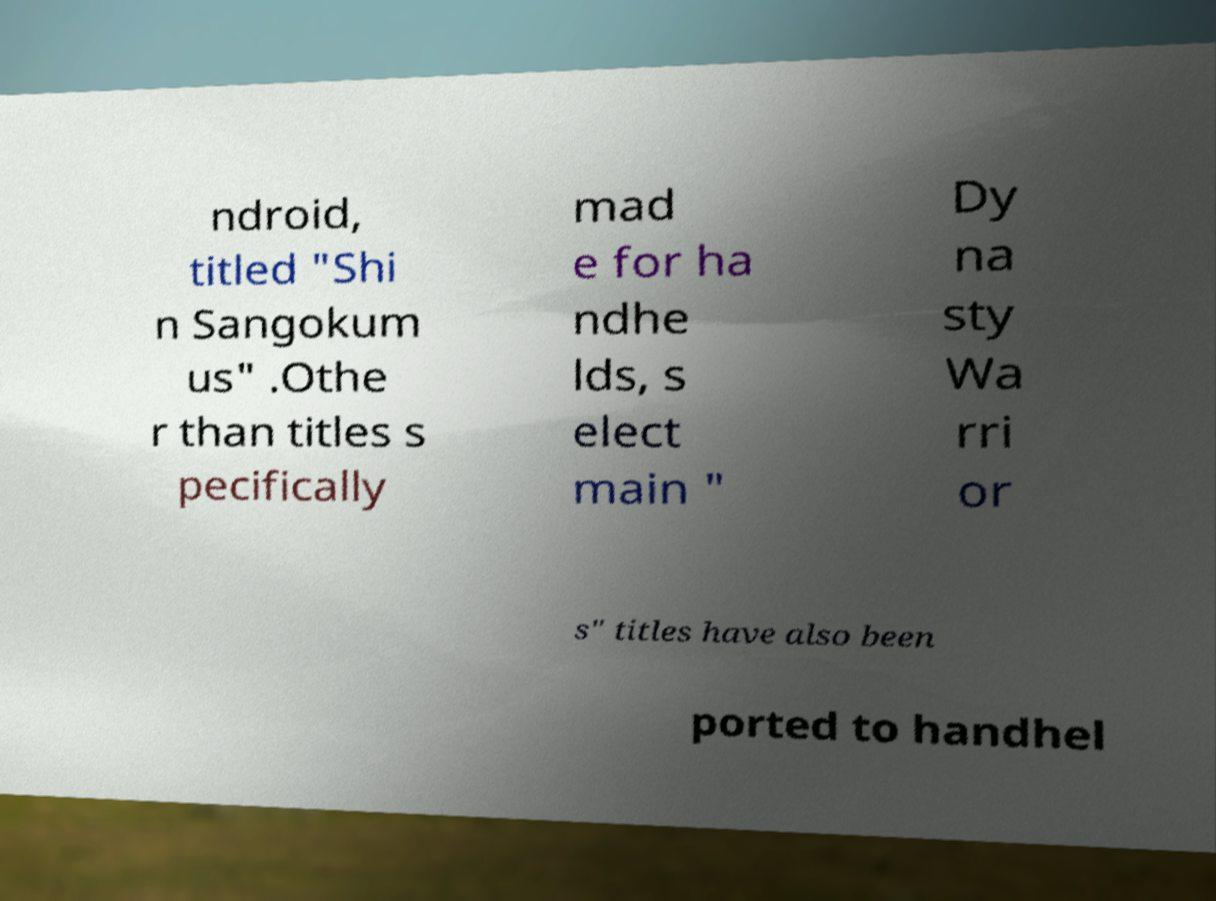Please read and relay the text visible in this image. What does it say? ndroid, titled "Shi n Sangokum us" .Othe r than titles s pecifically mad e for ha ndhe lds, s elect main " Dy na sty Wa rri or s" titles have also been ported to handhel 